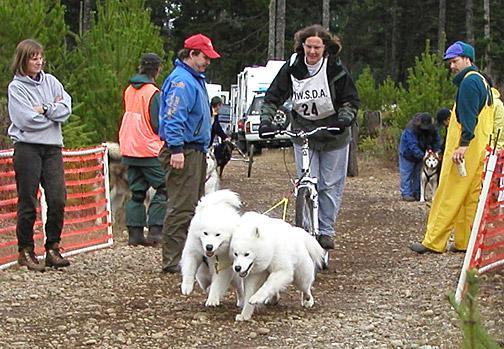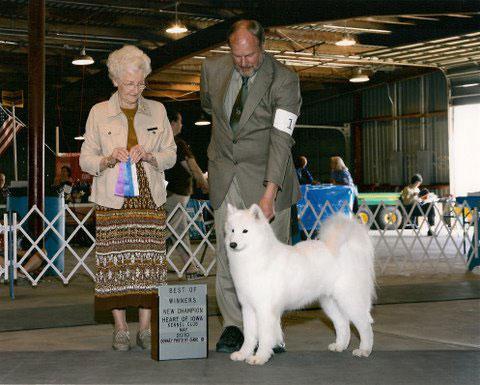The first image is the image on the left, the second image is the image on the right. For the images displayed, is the sentence "One image features a man in a suit reaching toward a standing white dog in front of white lattice fencing, and the other image features a team of hitched white dogs with a rider behind them." factually correct? Answer yes or no. Yes. The first image is the image on the left, the second image is the image on the right. For the images displayed, is the sentence "Dogs are running together." factually correct? Answer yes or no. Yes. 